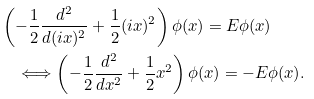Convert formula to latex. <formula><loc_0><loc_0><loc_500><loc_500>& \left ( - \frac { 1 } { 2 } \frac { d ^ { 2 } } { d ( i x ) ^ { 2 } } + \frac { 1 } { 2 } ( i x ) ^ { 2 } \right ) \phi ( x ) = E \phi ( x ) \\ & \quad \Longleftrightarrow \left ( - \frac { 1 } { 2 } \frac { d ^ { 2 } } { d x ^ { 2 } } + \frac { 1 } { 2 } x ^ { 2 } \right ) \phi ( x ) = - E \phi ( x ) .</formula> 